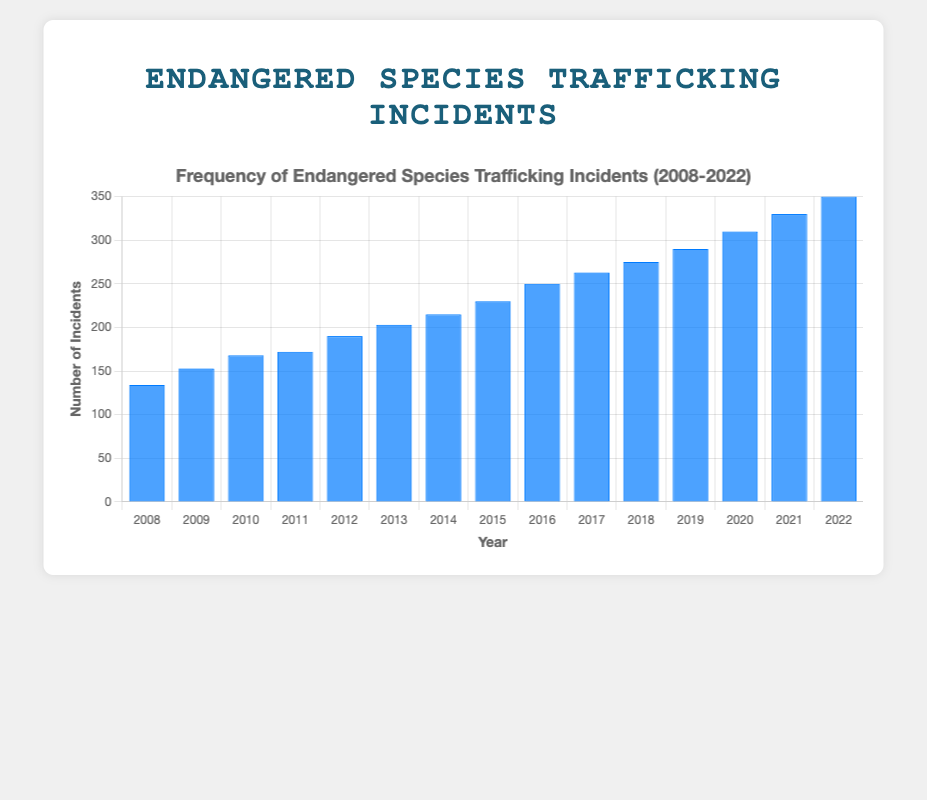What's the total number of endangered species trafficking incidents between 2008 and 2022? Sum the number of incidents for each year from 2008 to 2022: 134+153+168+172+190+203+215+230+250+263+275+290+310+330+350 = 3933 incidents
Answer: 3933 Which year had the highest number of incidents? Identify the year with the maximum value from the bar chart. The highest number of incidents is 350, which occurred in the year 2022.
Answer: 2022 How much did the number of incidents increase from 2008 to 2022? Subtract the number of incidents in 2008 from the number of incidents in 2022: 350 (2022) - 134 (2008) = 216 incidents
Answer: 216 Calculate the average number of incidents per year over this period. Divide the sum of incidents over the years (3933) by the number of years (15): 3933 / 15 ≈ 262.2 incidents per year
Answer: 262.2 Between which successive years was the largest increase in incidents observed? Calculate the year-to-year increases and identify the largest: 
2009-2008: 153-134=19,
2010-2009: 168-153=15,
2011-2010: 172-168=4,
2012-2011: 190-172=18,
2013-2012: 203-190=13,
2014-2013: 215-203=12,
2015-2014: 230-215=15,
2016-2015: 250-230=20,
2017-2016: 263-250=13,
2018-2017: 275-263=12,
2019-2018: 290-275=15,
2020-2019: 310-290=20,
2021-2020: 330-310=20,
2022-2021: 350-330=20,
The largest increase is from 2020 to 2021 as well as from 2021 to 2022, as they both show an increase of 20 incidents.
Answer: 2020-2021 and 2021-2022 How does the height of the bar in 2020 compare to the bar in 2010? Look at the height of the bars. The number of incidents in 2020 (310) is significantly higher than in 2010 (168). Subtract to find the difference in incidents: 310 - 168 = 142. This indicates a major increase visually.
Answer: 142 more in 2020 than 2010 What's the rate of increase in incidents from 2015 to 2020? Calculate the annual increase from 2015 (230 incidents) to 2020 (310 incidents). First find the total increment: 310 - 230 = 80. Then divide by the number of years: 80 / 5 = 16 incidents per year.
Answer: 16 Which year had fewer incidents, 2010 or 2011? Compare the heights of the bars for these two years. The bar for 2010 shows 168 incidents, and the bar for 2011 shows 172 incidents. Therefore, 2010 had fewer incidents than 2011.
Answer: 2010 Was there a continuous increase in incidents over the entire period? Observe the pattern of the bars from year to year. Each successive year shows a higher bar than the previous year, indicating a continuous increase in the number of incidents from 2008 to 2022.
Answer: Yes What is the trend observed in the graph regarding the number of incidents over the years? Visually assess the pattern of the bars. The height of the bars consistently increases, indicating a continuous upward trend in the frequency of endangered species trafficking incidents over the years.
Answer: Increasing trend 